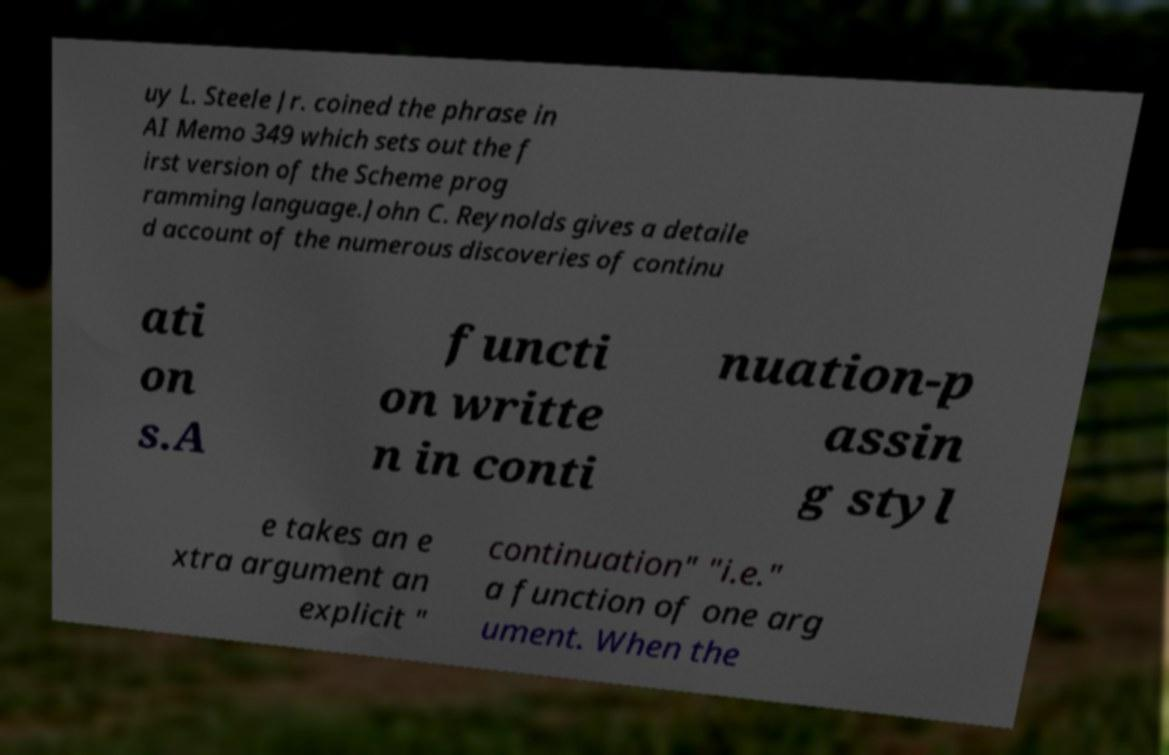Please identify and transcribe the text found in this image. uy L. Steele Jr. coined the phrase in AI Memo 349 which sets out the f irst version of the Scheme prog ramming language.John C. Reynolds gives a detaile d account of the numerous discoveries of continu ati on s.A functi on writte n in conti nuation-p assin g styl e takes an e xtra argument an explicit " continuation" "i.e." a function of one arg ument. When the 